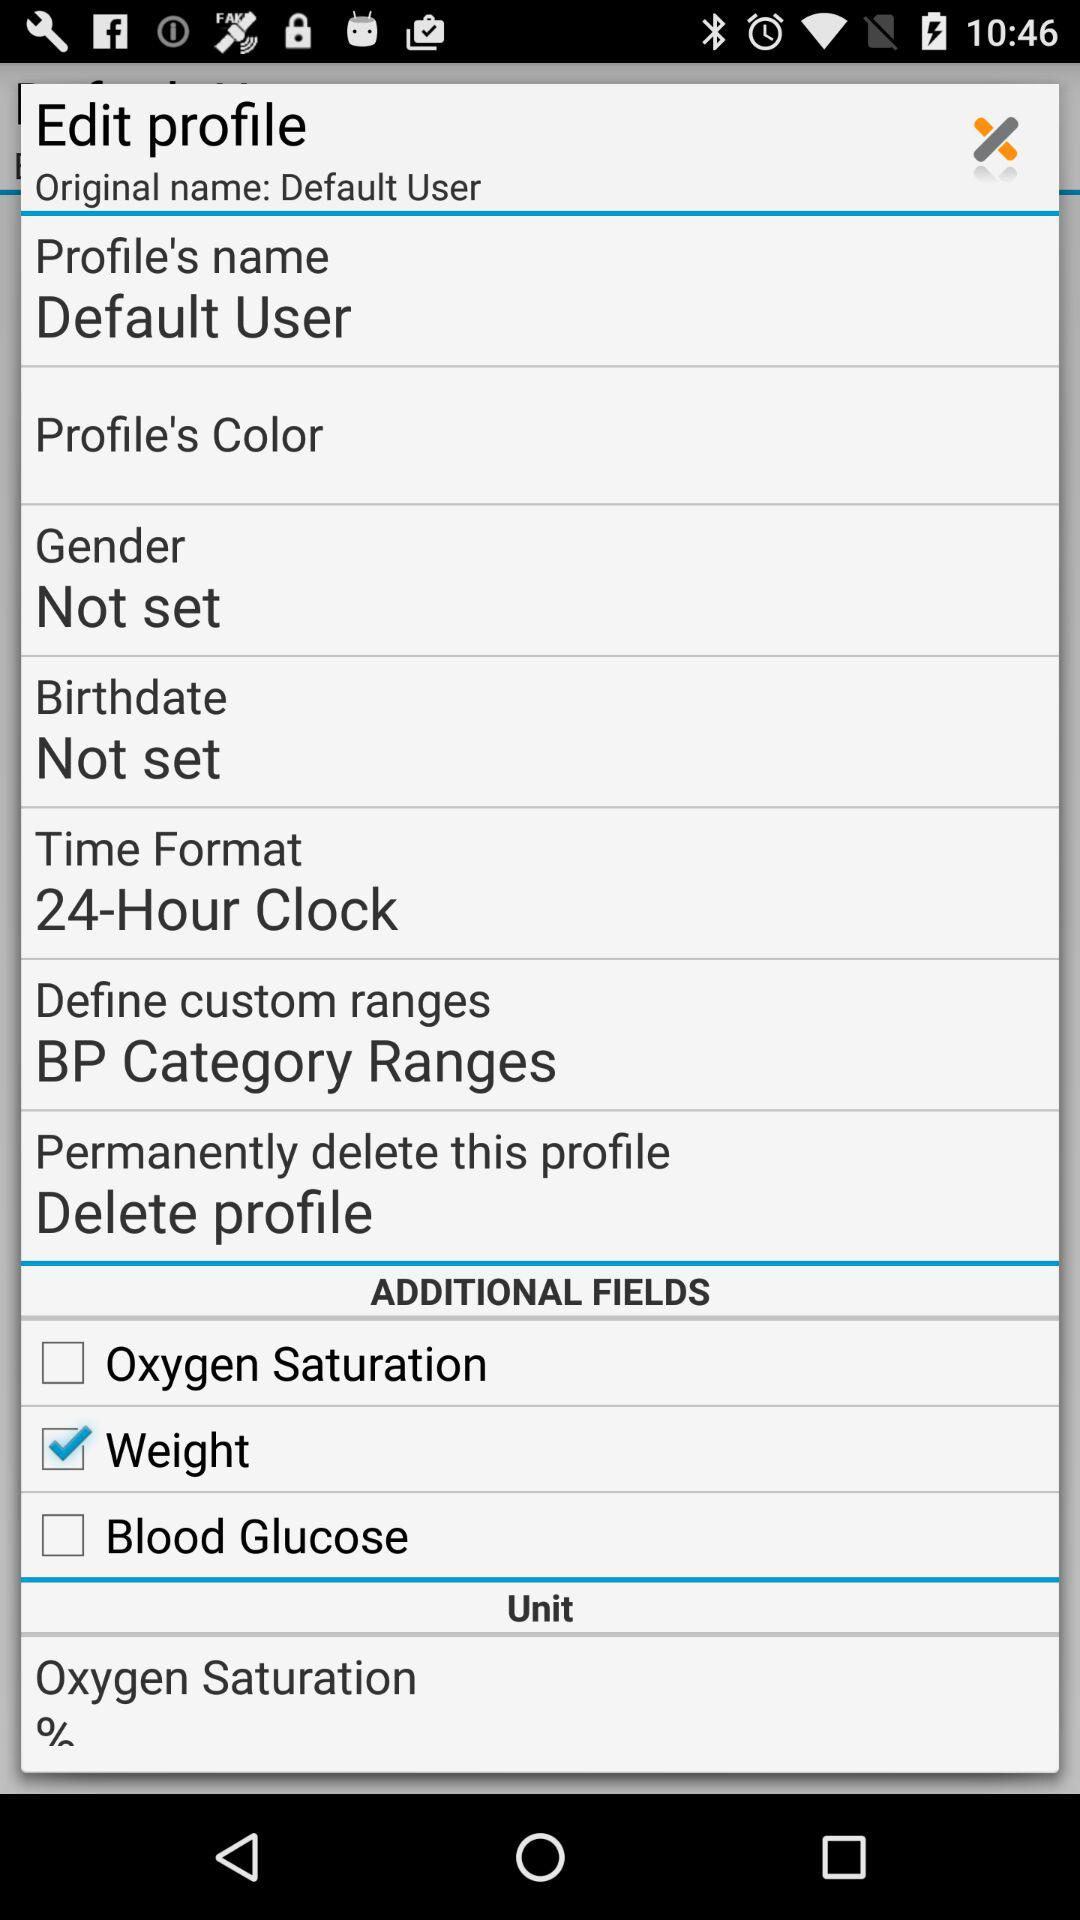How many fields are there in the additional fields section?
Answer the question using a single word or phrase. 3 